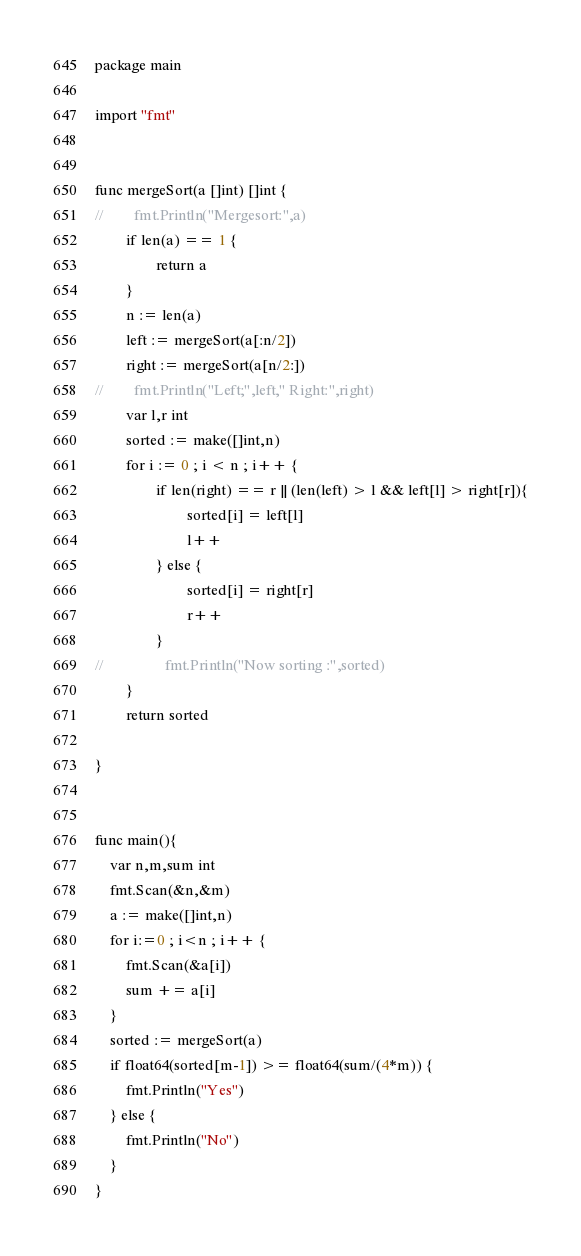<code> <loc_0><loc_0><loc_500><loc_500><_Go_>package main

import "fmt"


func mergeSort(a []int) []int {
//        fmt.Println("Mergesort:",a)
        if len(a) == 1 {
                return a
        }
        n := len(a)
        left := mergeSort(a[:n/2])
        right := mergeSort(a[n/2:])
//        fmt.Println("Left;",left," Right:",right)
        var l,r int
        sorted := make([]int,n)
        for i := 0 ; i < n ; i++ {
                if len(right) == r || (len(left) > l && left[l] > right[r]){
                        sorted[i] = left[l]
                        l++
                } else {
                        sorted[i] = right[r]
                        r++
                }
//                fmt.Println("Now sorting :",sorted)
        }
        return sorted

}


func main(){
	var n,m,sum int
	fmt.Scan(&n,&m)
	a := make([]int,n)
	for i:=0 ; i<n ; i++ {
		fmt.Scan(&a[i])
		sum += a[i]
	}
	sorted := mergeSort(a)
	if float64(sorted[m-1]) >= float64(sum/(4*m)) {
		fmt.Println("Yes")
	} else {
		fmt.Println("No")
	}
}
</code> 